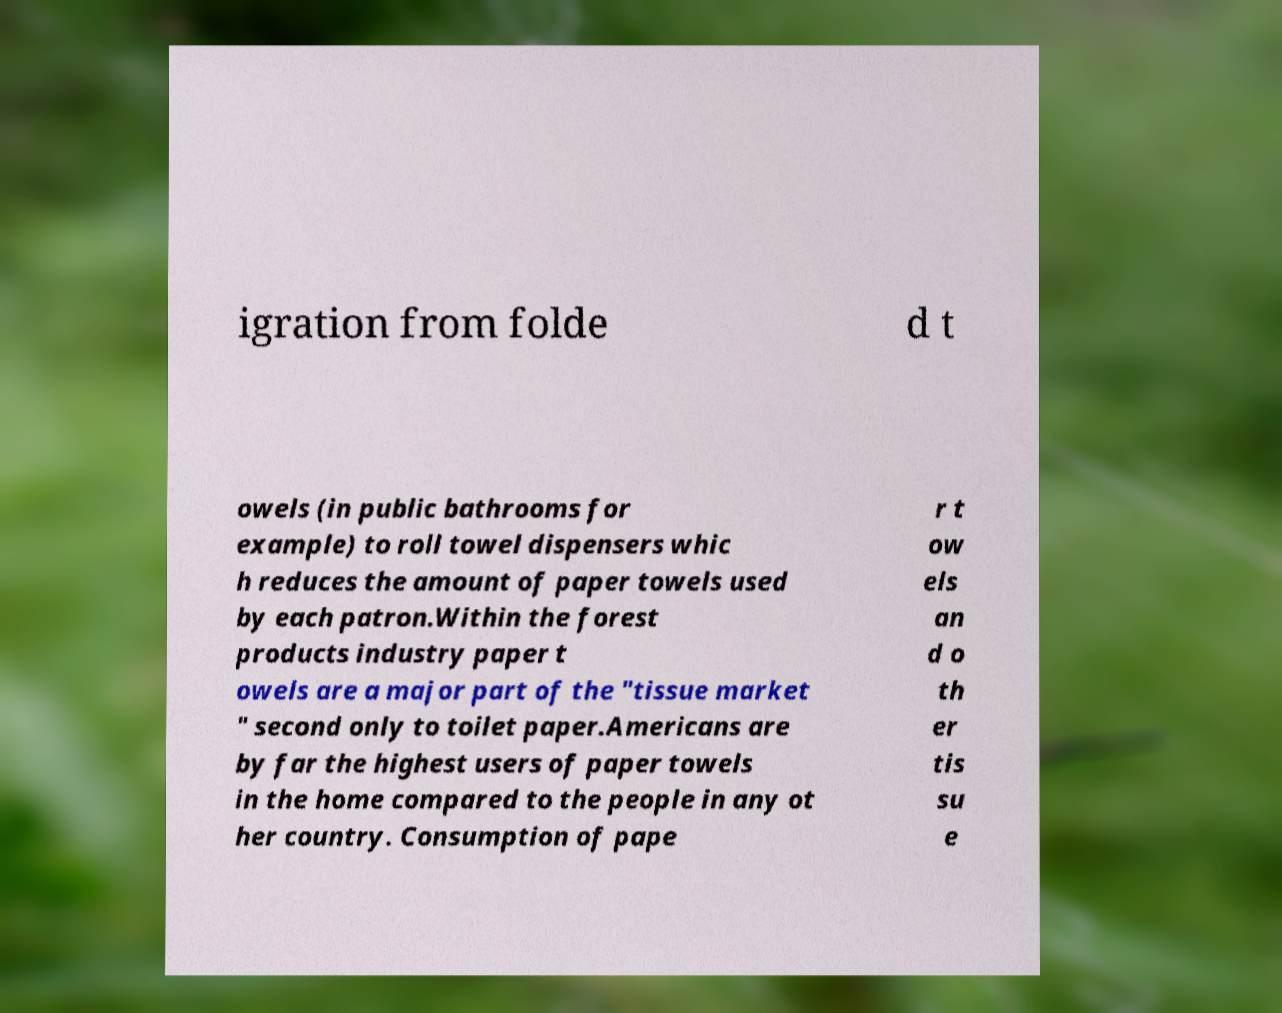For documentation purposes, I need the text within this image transcribed. Could you provide that? igration from folde d t owels (in public bathrooms for example) to roll towel dispensers whic h reduces the amount of paper towels used by each patron.Within the forest products industry paper t owels are a major part of the "tissue market " second only to toilet paper.Americans are by far the highest users of paper towels in the home compared to the people in any ot her country. Consumption of pape r t ow els an d o th er tis su e 